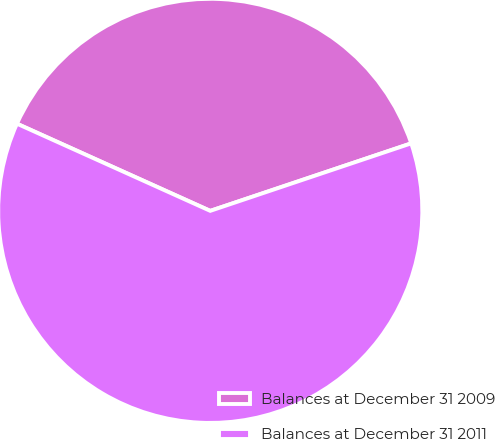Convert chart. <chart><loc_0><loc_0><loc_500><loc_500><pie_chart><fcel>Balances at December 31 2009<fcel>Balances at December 31 2011<nl><fcel>38.1%<fcel>61.9%<nl></chart> 